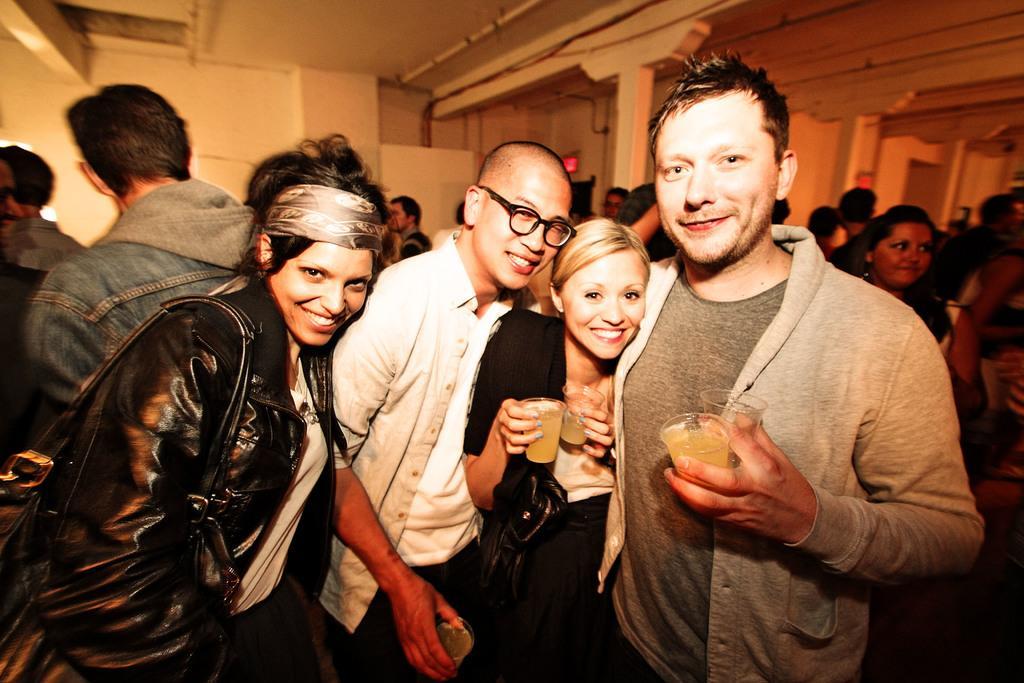Describe this image in one or two sentences. It is a party, there are a lot of people in a room and in the front there are four people were posing for the photo, they are smiling and also holding some glasses with their hand and in the background there is a wall. 